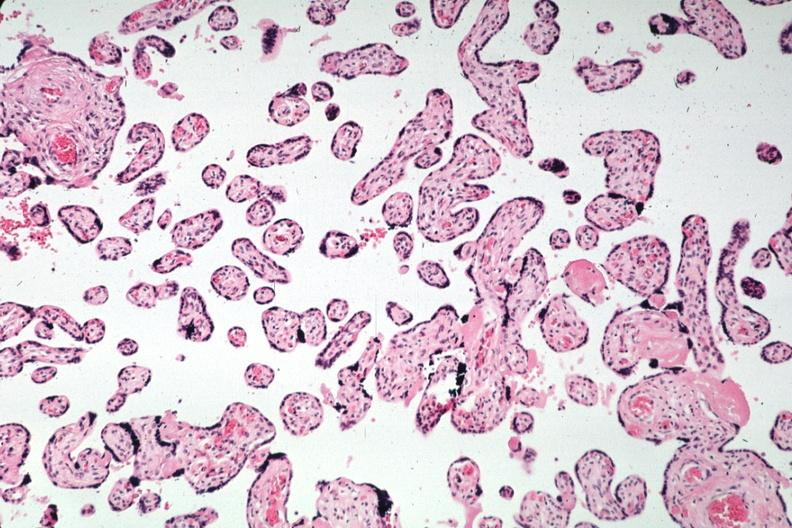s no cystic aortic lesions present?
Answer the question using a single word or phrase. No 